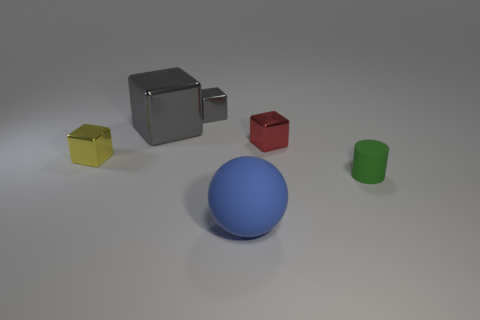What material is the cube that is in front of the small gray cube and behind the tiny red shiny object?
Offer a terse response. Metal. Are the big thing left of the large blue thing and the yellow block made of the same material?
Provide a short and direct response. Yes. What material is the blue sphere?
Offer a very short reply. Rubber. What is the size of the matte thing that is in front of the small green matte cylinder?
Provide a short and direct response. Large. Is there anything else that is the same color as the small cylinder?
Offer a terse response. No. Are there any red objects in front of the tiny cube that is right of the small metal block behind the small red shiny cube?
Your answer should be compact. No. There is a rubber thing that is in front of the tiny cylinder; is it the same color as the big block?
Give a very brief answer. No. What number of blocks are either blue matte objects or small gray shiny things?
Provide a succinct answer. 1. There is a tiny shiny object that is to the right of the rubber object that is in front of the green object; what shape is it?
Keep it short and to the point. Cube. There is a gray block to the left of the gray object right of the large shiny thing that is on the left side of the big blue matte ball; what is its size?
Your answer should be compact. Large. 